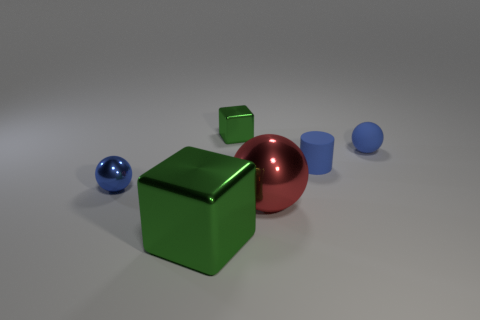There is a metal ball to the right of the big shiny block; is there a big block in front of it?
Ensure brevity in your answer.  Yes. Is the number of cylinders that are in front of the large cube less than the number of tiny blue objects that are to the left of the tiny blue rubber sphere?
Provide a succinct answer. Yes. Do the small blue object left of the red sphere and the green cube in front of the tiny rubber sphere have the same material?
Offer a very short reply. Yes. What number of tiny objects are cylinders or red shiny things?
Make the answer very short. 1. What shape is the tiny green thing that is the same material as the large green cube?
Give a very brief answer. Cube. Is the number of tiny things in front of the red thing less than the number of large brown matte objects?
Offer a terse response. No. Is the big green metal thing the same shape as the red shiny object?
Your response must be concise. No. What number of metal things are tiny blue spheres or tiny green objects?
Your answer should be compact. 2. Is there a purple rubber sphere that has the same size as the red object?
Give a very brief answer. No. What is the shape of the small metal object that is the same color as the large shiny cube?
Provide a short and direct response. Cube. 